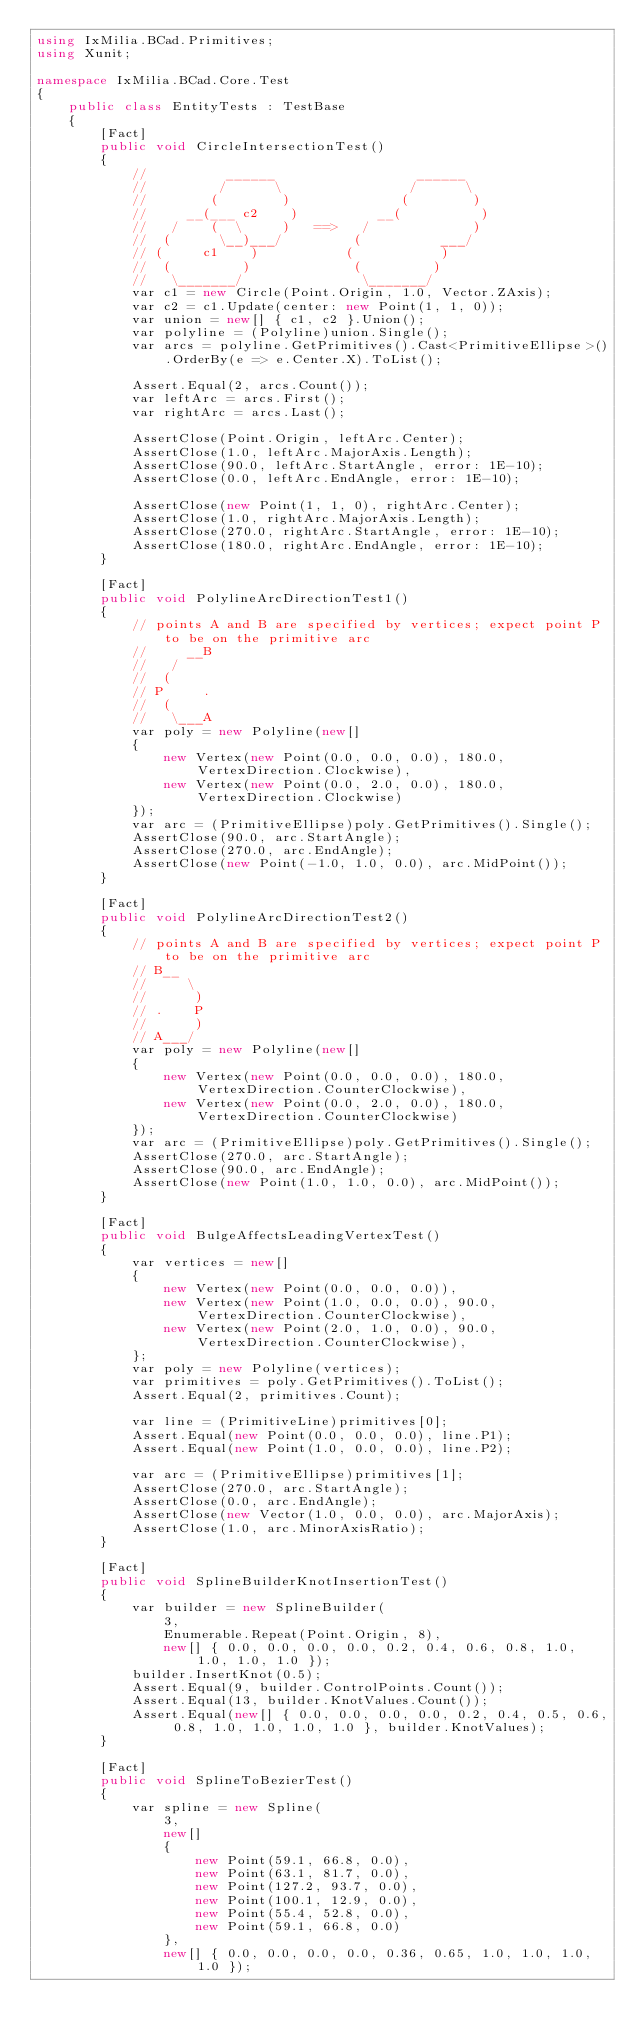Convert code to text. <code><loc_0><loc_0><loc_500><loc_500><_C#_>using IxMilia.BCad.Primitives;
using Xunit;

namespace IxMilia.BCad.Core.Test
{
    public class EntityTests : TestBase
    {
        [Fact]
        public void CircleIntersectionTest()
        {
            //          ______                  ______
            //         /      \                /      \
            //        (        )              (        )
            //     __(___ c2    )          __(          )
            //   /    (  \     )   ==>   /             )
            //  (      \__)___/         (          ___/
            // (     c1    )           (           )
            //  (         )             (         )
            //   \_______/               \_______/
            var c1 = new Circle(Point.Origin, 1.0, Vector.ZAxis);
            var c2 = c1.Update(center: new Point(1, 1, 0));
            var union = new[] { c1, c2 }.Union();
            var polyline = (Polyline)union.Single();
            var arcs = polyline.GetPrimitives().Cast<PrimitiveEllipse>().OrderBy(e => e.Center.X).ToList();

            Assert.Equal(2, arcs.Count());
            var leftArc = arcs.First();
            var rightArc = arcs.Last();

            AssertClose(Point.Origin, leftArc.Center);
            AssertClose(1.0, leftArc.MajorAxis.Length);
            AssertClose(90.0, leftArc.StartAngle, error: 1E-10);
            AssertClose(0.0, leftArc.EndAngle, error: 1E-10);

            AssertClose(new Point(1, 1, 0), rightArc.Center);
            AssertClose(1.0, rightArc.MajorAxis.Length);
            AssertClose(270.0, rightArc.StartAngle, error: 1E-10);
            AssertClose(180.0, rightArc.EndAngle, error: 1E-10);
        }

        [Fact]
        public void PolylineArcDirectionTest1()
        {
            // points A and B are specified by vertices; expect point P to be on the primitive arc
            //     __B
            //   /
            //  (
            // P     .
            //  (
            //   \___A
            var poly = new Polyline(new[]
            {
                new Vertex(new Point(0.0, 0.0, 0.0), 180.0, VertexDirection.Clockwise),
                new Vertex(new Point(0.0, 2.0, 0.0), 180.0, VertexDirection.Clockwise)
            });
            var arc = (PrimitiveEllipse)poly.GetPrimitives().Single();
            AssertClose(90.0, arc.StartAngle);
            AssertClose(270.0, arc.EndAngle);
            AssertClose(new Point(-1.0, 1.0, 0.0), arc.MidPoint());
        }

        [Fact]
        public void PolylineArcDirectionTest2()
        {
            // points A and B are specified by vertices; expect point P to be on the primitive arc
            // B__
            //     \
            //      )
            // .    P
            //      )
            // A___/
            var poly = new Polyline(new[]
            {
                new Vertex(new Point(0.0, 0.0, 0.0), 180.0, VertexDirection.CounterClockwise),
                new Vertex(new Point(0.0, 2.0, 0.0), 180.0, VertexDirection.CounterClockwise)
            });
            var arc = (PrimitiveEllipse)poly.GetPrimitives().Single();
            AssertClose(270.0, arc.StartAngle);
            AssertClose(90.0, arc.EndAngle);
            AssertClose(new Point(1.0, 1.0, 0.0), arc.MidPoint());
        }

        [Fact]
        public void BulgeAffectsLeadingVertexTest()
        {
            var vertices = new[]
            {
                new Vertex(new Point(0.0, 0.0, 0.0)),
                new Vertex(new Point(1.0, 0.0, 0.0), 90.0, VertexDirection.CounterClockwise),
                new Vertex(new Point(2.0, 1.0, 0.0), 90.0, VertexDirection.CounterClockwise),
            };
            var poly = new Polyline(vertices);
            var primitives = poly.GetPrimitives().ToList();
            Assert.Equal(2, primitives.Count);
            
            var line = (PrimitiveLine)primitives[0];
            Assert.Equal(new Point(0.0, 0.0, 0.0), line.P1);
            Assert.Equal(new Point(1.0, 0.0, 0.0), line.P2);

            var arc = (PrimitiveEllipse)primitives[1];
            AssertClose(270.0, arc.StartAngle);
            AssertClose(0.0, arc.EndAngle);
            AssertClose(new Vector(1.0, 0.0, 0.0), arc.MajorAxis);
            AssertClose(1.0, arc.MinorAxisRatio);
        }

        [Fact]
        public void SplineBuilderKnotInsertionTest()
        {
            var builder = new SplineBuilder(
                3,
                Enumerable.Repeat(Point.Origin, 8),
                new[] { 0.0, 0.0, 0.0, 0.0, 0.2, 0.4, 0.6, 0.8, 1.0, 1.0, 1.0, 1.0 });
            builder.InsertKnot(0.5);
            Assert.Equal(9, builder.ControlPoints.Count());
            Assert.Equal(13, builder.KnotValues.Count());
            Assert.Equal(new[] { 0.0, 0.0, 0.0, 0.0, 0.2, 0.4, 0.5, 0.6, 0.8, 1.0, 1.0, 1.0, 1.0 }, builder.KnotValues);
        }

        [Fact]
        public void SplineToBezierTest()
        {
            var spline = new Spline(
                3,
                new[]
                {
                    new Point(59.1, 66.8, 0.0),
                    new Point(63.1, 81.7, 0.0),
                    new Point(127.2, 93.7, 0.0),
                    new Point(100.1, 12.9, 0.0),
                    new Point(55.4, 52.8, 0.0),
                    new Point(59.1, 66.8, 0.0)
                },
                new[] { 0.0, 0.0, 0.0, 0.0, 0.36, 0.65, 1.0, 1.0, 1.0, 1.0 });</code> 